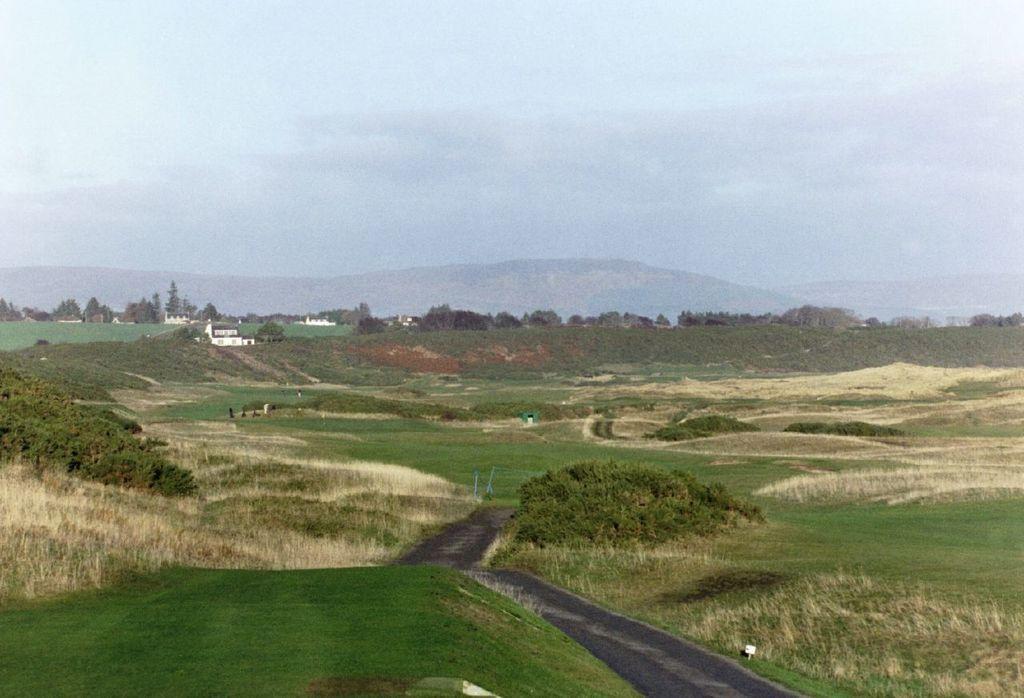Describe this image in one or two sentences. In this image I can see grass. There are trees, buildings, hills and in the background there is sky. 